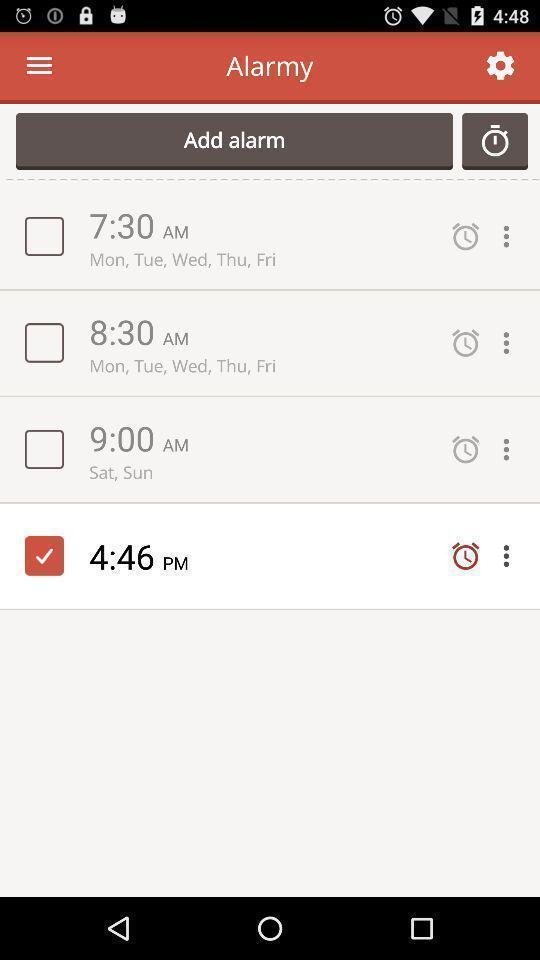Give me a summary of this screen capture. Set of alarms in an alarm app. 